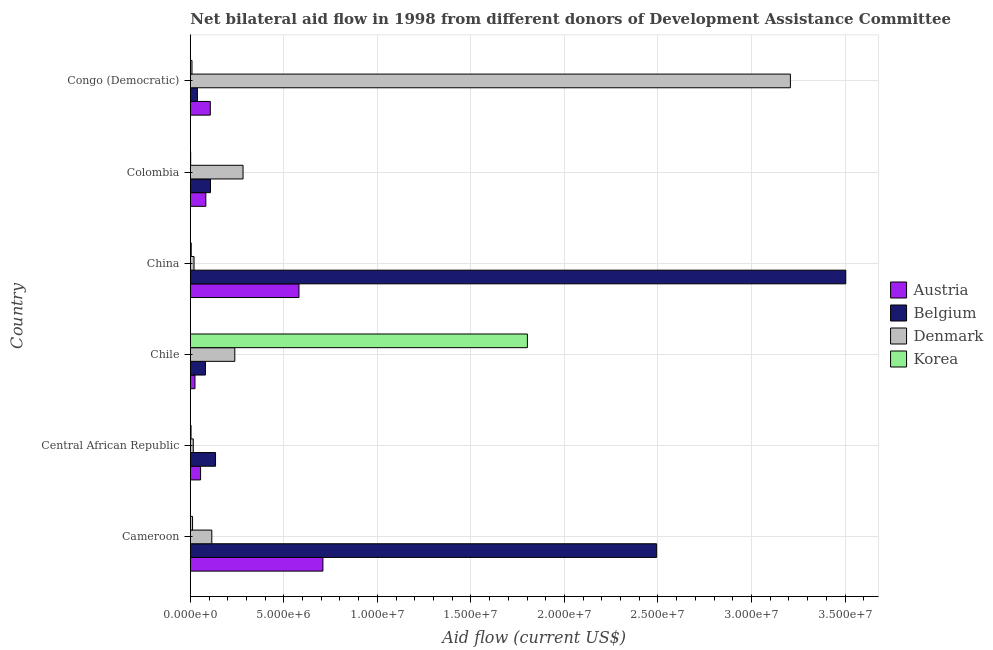How many bars are there on the 3rd tick from the bottom?
Your answer should be compact. 4. What is the label of the 4th group of bars from the top?
Provide a short and direct response. Chile. In how many cases, is the number of bars for a given country not equal to the number of legend labels?
Offer a very short reply. 0. What is the amount of aid given by belgium in Colombia?
Your response must be concise. 1.08e+06. Across all countries, what is the maximum amount of aid given by denmark?
Offer a terse response. 3.21e+07. Across all countries, what is the minimum amount of aid given by austria?
Offer a terse response. 2.50e+05. In which country was the amount of aid given by austria minimum?
Make the answer very short. Chile. What is the total amount of aid given by belgium in the graph?
Your answer should be very brief. 6.36e+07. What is the difference between the amount of aid given by korea in Cameroon and that in Chile?
Your answer should be compact. -1.79e+07. What is the difference between the amount of aid given by belgium in Cameroon and the amount of aid given by denmark in Chile?
Your answer should be very brief. 2.26e+07. What is the average amount of aid given by belgium per country?
Provide a succinct answer. 1.06e+07. What is the difference between the amount of aid given by korea and amount of aid given by belgium in Congo (Democratic)?
Your answer should be very brief. -2.90e+05. In how many countries, is the amount of aid given by belgium greater than 30000000 US$?
Provide a succinct answer. 1. Is the amount of aid given by belgium in Chile less than that in Colombia?
Ensure brevity in your answer.  Yes. What is the difference between the highest and the second highest amount of aid given by korea?
Make the answer very short. 1.79e+07. What is the difference between the highest and the lowest amount of aid given by denmark?
Keep it short and to the point. 3.19e+07. Is the sum of the amount of aid given by korea in Central African Republic and Congo (Democratic) greater than the maximum amount of aid given by denmark across all countries?
Offer a very short reply. No. Is it the case that in every country, the sum of the amount of aid given by korea and amount of aid given by austria is greater than the sum of amount of aid given by denmark and amount of aid given by belgium?
Ensure brevity in your answer.  Yes. What does the 1st bar from the bottom in Chile represents?
Your response must be concise. Austria. How many countries are there in the graph?
Keep it short and to the point. 6. What is the difference between two consecutive major ticks on the X-axis?
Ensure brevity in your answer.  5.00e+06. Where does the legend appear in the graph?
Your answer should be very brief. Center right. How many legend labels are there?
Your answer should be very brief. 4. How are the legend labels stacked?
Keep it short and to the point. Vertical. What is the title of the graph?
Make the answer very short. Net bilateral aid flow in 1998 from different donors of Development Assistance Committee. What is the label or title of the X-axis?
Provide a short and direct response. Aid flow (current US$). What is the label or title of the Y-axis?
Ensure brevity in your answer.  Country. What is the Aid flow (current US$) in Austria in Cameroon?
Your answer should be compact. 7.09e+06. What is the Aid flow (current US$) of Belgium in Cameroon?
Give a very brief answer. 2.49e+07. What is the Aid flow (current US$) in Denmark in Cameroon?
Provide a succinct answer. 1.15e+06. What is the Aid flow (current US$) in Austria in Central African Republic?
Keep it short and to the point. 5.50e+05. What is the Aid flow (current US$) of Belgium in Central African Republic?
Your response must be concise. 1.35e+06. What is the Aid flow (current US$) of Denmark in Central African Republic?
Ensure brevity in your answer.  1.60e+05. What is the Aid flow (current US$) of Austria in Chile?
Give a very brief answer. 2.50e+05. What is the Aid flow (current US$) in Belgium in Chile?
Provide a succinct answer. 8.10e+05. What is the Aid flow (current US$) of Denmark in Chile?
Your answer should be very brief. 2.38e+06. What is the Aid flow (current US$) in Korea in Chile?
Your answer should be very brief. 1.80e+07. What is the Aid flow (current US$) of Austria in China?
Provide a short and direct response. 5.81e+06. What is the Aid flow (current US$) of Belgium in China?
Your answer should be compact. 3.50e+07. What is the Aid flow (current US$) of Denmark in China?
Your answer should be compact. 2.00e+05. What is the Aid flow (current US$) of Korea in China?
Make the answer very short. 5.00e+04. What is the Aid flow (current US$) of Austria in Colombia?
Your response must be concise. 8.30e+05. What is the Aid flow (current US$) in Belgium in Colombia?
Offer a very short reply. 1.08e+06. What is the Aid flow (current US$) in Denmark in Colombia?
Offer a very short reply. 2.82e+06. What is the Aid flow (current US$) in Austria in Congo (Democratic)?
Ensure brevity in your answer.  1.07e+06. What is the Aid flow (current US$) of Belgium in Congo (Democratic)?
Give a very brief answer. 3.80e+05. What is the Aid flow (current US$) of Denmark in Congo (Democratic)?
Make the answer very short. 3.21e+07. Across all countries, what is the maximum Aid flow (current US$) in Austria?
Your response must be concise. 7.09e+06. Across all countries, what is the maximum Aid flow (current US$) in Belgium?
Ensure brevity in your answer.  3.50e+07. Across all countries, what is the maximum Aid flow (current US$) in Denmark?
Provide a short and direct response. 3.21e+07. Across all countries, what is the maximum Aid flow (current US$) in Korea?
Your response must be concise. 1.80e+07. Across all countries, what is the minimum Aid flow (current US$) of Belgium?
Provide a succinct answer. 3.80e+05. Across all countries, what is the minimum Aid flow (current US$) of Denmark?
Provide a succinct answer. 1.60e+05. What is the total Aid flow (current US$) in Austria in the graph?
Provide a short and direct response. 1.56e+07. What is the total Aid flow (current US$) of Belgium in the graph?
Make the answer very short. 6.36e+07. What is the total Aid flow (current US$) in Denmark in the graph?
Ensure brevity in your answer.  3.88e+07. What is the total Aid flow (current US$) of Korea in the graph?
Offer a very short reply. 1.83e+07. What is the difference between the Aid flow (current US$) in Austria in Cameroon and that in Central African Republic?
Provide a short and direct response. 6.54e+06. What is the difference between the Aid flow (current US$) of Belgium in Cameroon and that in Central African Republic?
Your answer should be very brief. 2.36e+07. What is the difference between the Aid flow (current US$) of Denmark in Cameroon and that in Central African Republic?
Provide a short and direct response. 9.90e+05. What is the difference between the Aid flow (current US$) in Korea in Cameroon and that in Central African Republic?
Ensure brevity in your answer.  8.00e+04. What is the difference between the Aid flow (current US$) in Austria in Cameroon and that in Chile?
Offer a very short reply. 6.84e+06. What is the difference between the Aid flow (current US$) in Belgium in Cameroon and that in Chile?
Provide a short and direct response. 2.41e+07. What is the difference between the Aid flow (current US$) of Denmark in Cameroon and that in Chile?
Your response must be concise. -1.23e+06. What is the difference between the Aid flow (current US$) in Korea in Cameroon and that in Chile?
Offer a very short reply. -1.79e+07. What is the difference between the Aid flow (current US$) of Austria in Cameroon and that in China?
Provide a short and direct response. 1.28e+06. What is the difference between the Aid flow (current US$) in Belgium in Cameroon and that in China?
Your answer should be very brief. -1.01e+07. What is the difference between the Aid flow (current US$) in Denmark in Cameroon and that in China?
Your answer should be compact. 9.50e+05. What is the difference between the Aid flow (current US$) of Korea in Cameroon and that in China?
Your response must be concise. 7.00e+04. What is the difference between the Aid flow (current US$) of Austria in Cameroon and that in Colombia?
Your answer should be very brief. 6.26e+06. What is the difference between the Aid flow (current US$) in Belgium in Cameroon and that in Colombia?
Provide a succinct answer. 2.38e+07. What is the difference between the Aid flow (current US$) of Denmark in Cameroon and that in Colombia?
Offer a very short reply. -1.67e+06. What is the difference between the Aid flow (current US$) in Korea in Cameroon and that in Colombia?
Keep it short and to the point. 1.00e+05. What is the difference between the Aid flow (current US$) of Austria in Cameroon and that in Congo (Democratic)?
Provide a short and direct response. 6.02e+06. What is the difference between the Aid flow (current US$) of Belgium in Cameroon and that in Congo (Democratic)?
Keep it short and to the point. 2.46e+07. What is the difference between the Aid flow (current US$) of Denmark in Cameroon and that in Congo (Democratic)?
Keep it short and to the point. -3.09e+07. What is the difference between the Aid flow (current US$) in Korea in Cameroon and that in Congo (Democratic)?
Make the answer very short. 3.00e+04. What is the difference between the Aid flow (current US$) of Belgium in Central African Republic and that in Chile?
Your response must be concise. 5.40e+05. What is the difference between the Aid flow (current US$) in Denmark in Central African Republic and that in Chile?
Make the answer very short. -2.22e+06. What is the difference between the Aid flow (current US$) in Korea in Central African Republic and that in Chile?
Ensure brevity in your answer.  -1.80e+07. What is the difference between the Aid flow (current US$) in Austria in Central African Republic and that in China?
Provide a succinct answer. -5.26e+06. What is the difference between the Aid flow (current US$) of Belgium in Central African Republic and that in China?
Your answer should be very brief. -3.37e+07. What is the difference between the Aid flow (current US$) of Austria in Central African Republic and that in Colombia?
Provide a short and direct response. -2.80e+05. What is the difference between the Aid flow (current US$) in Denmark in Central African Republic and that in Colombia?
Give a very brief answer. -2.66e+06. What is the difference between the Aid flow (current US$) of Austria in Central African Republic and that in Congo (Democratic)?
Your response must be concise. -5.20e+05. What is the difference between the Aid flow (current US$) in Belgium in Central African Republic and that in Congo (Democratic)?
Offer a very short reply. 9.70e+05. What is the difference between the Aid flow (current US$) of Denmark in Central African Republic and that in Congo (Democratic)?
Offer a very short reply. -3.19e+07. What is the difference between the Aid flow (current US$) of Austria in Chile and that in China?
Provide a succinct answer. -5.56e+06. What is the difference between the Aid flow (current US$) in Belgium in Chile and that in China?
Your response must be concise. -3.42e+07. What is the difference between the Aid flow (current US$) of Denmark in Chile and that in China?
Provide a succinct answer. 2.18e+06. What is the difference between the Aid flow (current US$) of Korea in Chile and that in China?
Keep it short and to the point. 1.80e+07. What is the difference between the Aid flow (current US$) in Austria in Chile and that in Colombia?
Offer a very short reply. -5.80e+05. What is the difference between the Aid flow (current US$) of Belgium in Chile and that in Colombia?
Your response must be concise. -2.70e+05. What is the difference between the Aid flow (current US$) in Denmark in Chile and that in Colombia?
Your answer should be compact. -4.40e+05. What is the difference between the Aid flow (current US$) of Korea in Chile and that in Colombia?
Provide a short and direct response. 1.80e+07. What is the difference between the Aid flow (current US$) of Austria in Chile and that in Congo (Democratic)?
Your answer should be very brief. -8.20e+05. What is the difference between the Aid flow (current US$) in Denmark in Chile and that in Congo (Democratic)?
Offer a very short reply. -2.97e+07. What is the difference between the Aid flow (current US$) in Korea in Chile and that in Congo (Democratic)?
Offer a terse response. 1.79e+07. What is the difference between the Aid flow (current US$) of Austria in China and that in Colombia?
Make the answer very short. 4.98e+06. What is the difference between the Aid flow (current US$) of Belgium in China and that in Colombia?
Your answer should be very brief. 3.40e+07. What is the difference between the Aid flow (current US$) of Denmark in China and that in Colombia?
Your answer should be very brief. -2.62e+06. What is the difference between the Aid flow (current US$) in Austria in China and that in Congo (Democratic)?
Ensure brevity in your answer.  4.74e+06. What is the difference between the Aid flow (current US$) in Belgium in China and that in Congo (Democratic)?
Ensure brevity in your answer.  3.47e+07. What is the difference between the Aid flow (current US$) of Denmark in China and that in Congo (Democratic)?
Offer a terse response. -3.19e+07. What is the difference between the Aid flow (current US$) of Korea in China and that in Congo (Democratic)?
Offer a terse response. -4.00e+04. What is the difference between the Aid flow (current US$) in Belgium in Colombia and that in Congo (Democratic)?
Your answer should be compact. 7.00e+05. What is the difference between the Aid flow (current US$) of Denmark in Colombia and that in Congo (Democratic)?
Provide a short and direct response. -2.93e+07. What is the difference between the Aid flow (current US$) in Korea in Colombia and that in Congo (Democratic)?
Offer a very short reply. -7.00e+04. What is the difference between the Aid flow (current US$) in Austria in Cameroon and the Aid flow (current US$) in Belgium in Central African Republic?
Your answer should be compact. 5.74e+06. What is the difference between the Aid flow (current US$) of Austria in Cameroon and the Aid flow (current US$) of Denmark in Central African Republic?
Your response must be concise. 6.93e+06. What is the difference between the Aid flow (current US$) of Austria in Cameroon and the Aid flow (current US$) of Korea in Central African Republic?
Give a very brief answer. 7.05e+06. What is the difference between the Aid flow (current US$) in Belgium in Cameroon and the Aid flow (current US$) in Denmark in Central African Republic?
Keep it short and to the point. 2.48e+07. What is the difference between the Aid flow (current US$) in Belgium in Cameroon and the Aid flow (current US$) in Korea in Central African Republic?
Your answer should be very brief. 2.49e+07. What is the difference between the Aid flow (current US$) of Denmark in Cameroon and the Aid flow (current US$) of Korea in Central African Republic?
Your answer should be compact. 1.11e+06. What is the difference between the Aid flow (current US$) in Austria in Cameroon and the Aid flow (current US$) in Belgium in Chile?
Give a very brief answer. 6.28e+06. What is the difference between the Aid flow (current US$) of Austria in Cameroon and the Aid flow (current US$) of Denmark in Chile?
Make the answer very short. 4.71e+06. What is the difference between the Aid flow (current US$) in Austria in Cameroon and the Aid flow (current US$) in Korea in Chile?
Give a very brief answer. -1.09e+07. What is the difference between the Aid flow (current US$) in Belgium in Cameroon and the Aid flow (current US$) in Denmark in Chile?
Keep it short and to the point. 2.26e+07. What is the difference between the Aid flow (current US$) of Belgium in Cameroon and the Aid flow (current US$) of Korea in Chile?
Keep it short and to the point. 6.91e+06. What is the difference between the Aid flow (current US$) of Denmark in Cameroon and the Aid flow (current US$) of Korea in Chile?
Your answer should be compact. -1.69e+07. What is the difference between the Aid flow (current US$) in Austria in Cameroon and the Aid flow (current US$) in Belgium in China?
Your answer should be compact. -2.80e+07. What is the difference between the Aid flow (current US$) in Austria in Cameroon and the Aid flow (current US$) in Denmark in China?
Keep it short and to the point. 6.89e+06. What is the difference between the Aid flow (current US$) in Austria in Cameroon and the Aid flow (current US$) in Korea in China?
Give a very brief answer. 7.04e+06. What is the difference between the Aid flow (current US$) in Belgium in Cameroon and the Aid flow (current US$) in Denmark in China?
Your answer should be very brief. 2.47e+07. What is the difference between the Aid flow (current US$) in Belgium in Cameroon and the Aid flow (current US$) in Korea in China?
Your answer should be compact. 2.49e+07. What is the difference between the Aid flow (current US$) of Denmark in Cameroon and the Aid flow (current US$) of Korea in China?
Your answer should be compact. 1.10e+06. What is the difference between the Aid flow (current US$) in Austria in Cameroon and the Aid flow (current US$) in Belgium in Colombia?
Offer a very short reply. 6.01e+06. What is the difference between the Aid flow (current US$) in Austria in Cameroon and the Aid flow (current US$) in Denmark in Colombia?
Provide a succinct answer. 4.27e+06. What is the difference between the Aid flow (current US$) in Austria in Cameroon and the Aid flow (current US$) in Korea in Colombia?
Offer a terse response. 7.07e+06. What is the difference between the Aid flow (current US$) of Belgium in Cameroon and the Aid flow (current US$) of Denmark in Colombia?
Offer a very short reply. 2.21e+07. What is the difference between the Aid flow (current US$) in Belgium in Cameroon and the Aid flow (current US$) in Korea in Colombia?
Your response must be concise. 2.49e+07. What is the difference between the Aid flow (current US$) in Denmark in Cameroon and the Aid flow (current US$) in Korea in Colombia?
Your response must be concise. 1.13e+06. What is the difference between the Aid flow (current US$) in Austria in Cameroon and the Aid flow (current US$) in Belgium in Congo (Democratic)?
Provide a short and direct response. 6.71e+06. What is the difference between the Aid flow (current US$) of Austria in Cameroon and the Aid flow (current US$) of Denmark in Congo (Democratic)?
Your response must be concise. -2.50e+07. What is the difference between the Aid flow (current US$) of Belgium in Cameroon and the Aid flow (current US$) of Denmark in Congo (Democratic)?
Your answer should be compact. -7.15e+06. What is the difference between the Aid flow (current US$) in Belgium in Cameroon and the Aid flow (current US$) in Korea in Congo (Democratic)?
Keep it short and to the point. 2.48e+07. What is the difference between the Aid flow (current US$) of Denmark in Cameroon and the Aid flow (current US$) of Korea in Congo (Democratic)?
Provide a short and direct response. 1.06e+06. What is the difference between the Aid flow (current US$) of Austria in Central African Republic and the Aid flow (current US$) of Belgium in Chile?
Make the answer very short. -2.60e+05. What is the difference between the Aid flow (current US$) in Austria in Central African Republic and the Aid flow (current US$) in Denmark in Chile?
Keep it short and to the point. -1.83e+06. What is the difference between the Aid flow (current US$) in Austria in Central African Republic and the Aid flow (current US$) in Korea in Chile?
Offer a very short reply. -1.75e+07. What is the difference between the Aid flow (current US$) in Belgium in Central African Republic and the Aid flow (current US$) in Denmark in Chile?
Give a very brief answer. -1.03e+06. What is the difference between the Aid flow (current US$) of Belgium in Central African Republic and the Aid flow (current US$) of Korea in Chile?
Your answer should be compact. -1.67e+07. What is the difference between the Aid flow (current US$) in Denmark in Central African Republic and the Aid flow (current US$) in Korea in Chile?
Offer a very short reply. -1.79e+07. What is the difference between the Aid flow (current US$) of Austria in Central African Republic and the Aid flow (current US$) of Belgium in China?
Give a very brief answer. -3.45e+07. What is the difference between the Aid flow (current US$) in Austria in Central African Republic and the Aid flow (current US$) in Korea in China?
Provide a short and direct response. 5.00e+05. What is the difference between the Aid flow (current US$) in Belgium in Central African Republic and the Aid flow (current US$) in Denmark in China?
Ensure brevity in your answer.  1.15e+06. What is the difference between the Aid flow (current US$) of Belgium in Central African Republic and the Aid flow (current US$) of Korea in China?
Keep it short and to the point. 1.30e+06. What is the difference between the Aid flow (current US$) in Denmark in Central African Republic and the Aid flow (current US$) in Korea in China?
Your answer should be very brief. 1.10e+05. What is the difference between the Aid flow (current US$) of Austria in Central African Republic and the Aid flow (current US$) of Belgium in Colombia?
Your answer should be very brief. -5.30e+05. What is the difference between the Aid flow (current US$) of Austria in Central African Republic and the Aid flow (current US$) of Denmark in Colombia?
Your answer should be very brief. -2.27e+06. What is the difference between the Aid flow (current US$) in Austria in Central African Republic and the Aid flow (current US$) in Korea in Colombia?
Your answer should be very brief. 5.30e+05. What is the difference between the Aid flow (current US$) of Belgium in Central African Republic and the Aid flow (current US$) of Denmark in Colombia?
Ensure brevity in your answer.  -1.47e+06. What is the difference between the Aid flow (current US$) of Belgium in Central African Republic and the Aid flow (current US$) of Korea in Colombia?
Provide a succinct answer. 1.33e+06. What is the difference between the Aid flow (current US$) in Austria in Central African Republic and the Aid flow (current US$) in Denmark in Congo (Democratic)?
Provide a short and direct response. -3.15e+07. What is the difference between the Aid flow (current US$) in Belgium in Central African Republic and the Aid flow (current US$) in Denmark in Congo (Democratic)?
Offer a terse response. -3.07e+07. What is the difference between the Aid flow (current US$) in Belgium in Central African Republic and the Aid flow (current US$) in Korea in Congo (Democratic)?
Your answer should be compact. 1.26e+06. What is the difference between the Aid flow (current US$) in Austria in Chile and the Aid flow (current US$) in Belgium in China?
Your answer should be compact. -3.48e+07. What is the difference between the Aid flow (current US$) of Austria in Chile and the Aid flow (current US$) of Denmark in China?
Keep it short and to the point. 5.00e+04. What is the difference between the Aid flow (current US$) of Austria in Chile and the Aid flow (current US$) of Korea in China?
Keep it short and to the point. 2.00e+05. What is the difference between the Aid flow (current US$) in Belgium in Chile and the Aid flow (current US$) in Denmark in China?
Give a very brief answer. 6.10e+05. What is the difference between the Aid flow (current US$) in Belgium in Chile and the Aid flow (current US$) in Korea in China?
Make the answer very short. 7.60e+05. What is the difference between the Aid flow (current US$) of Denmark in Chile and the Aid flow (current US$) of Korea in China?
Your answer should be compact. 2.33e+06. What is the difference between the Aid flow (current US$) of Austria in Chile and the Aid flow (current US$) of Belgium in Colombia?
Ensure brevity in your answer.  -8.30e+05. What is the difference between the Aid flow (current US$) of Austria in Chile and the Aid flow (current US$) of Denmark in Colombia?
Your response must be concise. -2.57e+06. What is the difference between the Aid flow (current US$) in Austria in Chile and the Aid flow (current US$) in Korea in Colombia?
Your answer should be very brief. 2.30e+05. What is the difference between the Aid flow (current US$) of Belgium in Chile and the Aid flow (current US$) of Denmark in Colombia?
Give a very brief answer. -2.01e+06. What is the difference between the Aid flow (current US$) in Belgium in Chile and the Aid flow (current US$) in Korea in Colombia?
Your answer should be very brief. 7.90e+05. What is the difference between the Aid flow (current US$) in Denmark in Chile and the Aid flow (current US$) in Korea in Colombia?
Ensure brevity in your answer.  2.36e+06. What is the difference between the Aid flow (current US$) of Austria in Chile and the Aid flow (current US$) of Belgium in Congo (Democratic)?
Offer a terse response. -1.30e+05. What is the difference between the Aid flow (current US$) of Austria in Chile and the Aid flow (current US$) of Denmark in Congo (Democratic)?
Offer a terse response. -3.18e+07. What is the difference between the Aid flow (current US$) of Belgium in Chile and the Aid flow (current US$) of Denmark in Congo (Democratic)?
Your answer should be compact. -3.13e+07. What is the difference between the Aid flow (current US$) in Belgium in Chile and the Aid flow (current US$) in Korea in Congo (Democratic)?
Provide a short and direct response. 7.20e+05. What is the difference between the Aid flow (current US$) in Denmark in Chile and the Aid flow (current US$) in Korea in Congo (Democratic)?
Keep it short and to the point. 2.29e+06. What is the difference between the Aid flow (current US$) of Austria in China and the Aid flow (current US$) of Belgium in Colombia?
Provide a short and direct response. 4.73e+06. What is the difference between the Aid flow (current US$) in Austria in China and the Aid flow (current US$) in Denmark in Colombia?
Offer a very short reply. 2.99e+06. What is the difference between the Aid flow (current US$) of Austria in China and the Aid flow (current US$) of Korea in Colombia?
Keep it short and to the point. 5.79e+06. What is the difference between the Aid flow (current US$) in Belgium in China and the Aid flow (current US$) in Denmark in Colombia?
Provide a short and direct response. 3.22e+07. What is the difference between the Aid flow (current US$) in Belgium in China and the Aid flow (current US$) in Korea in Colombia?
Give a very brief answer. 3.50e+07. What is the difference between the Aid flow (current US$) of Denmark in China and the Aid flow (current US$) of Korea in Colombia?
Your answer should be compact. 1.80e+05. What is the difference between the Aid flow (current US$) of Austria in China and the Aid flow (current US$) of Belgium in Congo (Democratic)?
Your response must be concise. 5.43e+06. What is the difference between the Aid flow (current US$) of Austria in China and the Aid flow (current US$) of Denmark in Congo (Democratic)?
Offer a terse response. -2.63e+07. What is the difference between the Aid flow (current US$) of Austria in China and the Aid flow (current US$) of Korea in Congo (Democratic)?
Keep it short and to the point. 5.72e+06. What is the difference between the Aid flow (current US$) of Belgium in China and the Aid flow (current US$) of Denmark in Congo (Democratic)?
Ensure brevity in your answer.  2.96e+06. What is the difference between the Aid flow (current US$) of Belgium in China and the Aid flow (current US$) of Korea in Congo (Democratic)?
Offer a terse response. 3.50e+07. What is the difference between the Aid flow (current US$) of Austria in Colombia and the Aid flow (current US$) of Denmark in Congo (Democratic)?
Offer a very short reply. -3.12e+07. What is the difference between the Aid flow (current US$) in Austria in Colombia and the Aid flow (current US$) in Korea in Congo (Democratic)?
Make the answer very short. 7.40e+05. What is the difference between the Aid flow (current US$) in Belgium in Colombia and the Aid flow (current US$) in Denmark in Congo (Democratic)?
Your answer should be very brief. -3.10e+07. What is the difference between the Aid flow (current US$) of Belgium in Colombia and the Aid flow (current US$) of Korea in Congo (Democratic)?
Keep it short and to the point. 9.90e+05. What is the difference between the Aid flow (current US$) of Denmark in Colombia and the Aid flow (current US$) of Korea in Congo (Democratic)?
Offer a terse response. 2.73e+06. What is the average Aid flow (current US$) of Austria per country?
Offer a terse response. 2.60e+06. What is the average Aid flow (current US$) of Belgium per country?
Make the answer very short. 1.06e+07. What is the average Aid flow (current US$) in Denmark per country?
Your response must be concise. 6.46e+06. What is the average Aid flow (current US$) of Korea per country?
Offer a terse response. 3.06e+06. What is the difference between the Aid flow (current US$) in Austria and Aid flow (current US$) in Belgium in Cameroon?
Offer a terse response. -1.78e+07. What is the difference between the Aid flow (current US$) of Austria and Aid flow (current US$) of Denmark in Cameroon?
Provide a short and direct response. 5.94e+06. What is the difference between the Aid flow (current US$) in Austria and Aid flow (current US$) in Korea in Cameroon?
Ensure brevity in your answer.  6.97e+06. What is the difference between the Aid flow (current US$) of Belgium and Aid flow (current US$) of Denmark in Cameroon?
Your answer should be very brief. 2.38e+07. What is the difference between the Aid flow (current US$) of Belgium and Aid flow (current US$) of Korea in Cameroon?
Your response must be concise. 2.48e+07. What is the difference between the Aid flow (current US$) in Denmark and Aid flow (current US$) in Korea in Cameroon?
Keep it short and to the point. 1.03e+06. What is the difference between the Aid flow (current US$) of Austria and Aid flow (current US$) of Belgium in Central African Republic?
Ensure brevity in your answer.  -8.00e+05. What is the difference between the Aid flow (current US$) in Austria and Aid flow (current US$) in Denmark in Central African Republic?
Keep it short and to the point. 3.90e+05. What is the difference between the Aid flow (current US$) of Austria and Aid flow (current US$) of Korea in Central African Republic?
Provide a succinct answer. 5.10e+05. What is the difference between the Aid flow (current US$) of Belgium and Aid flow (current US$) of Denmark in Central African Republic?
Ensure brevity in your answer.  1.19e+06. What is the difference between the Aid flow (current US$) of Belgium and Aid flow (current US$) of Korea in Central African Republic?
Your response must be concise. 1.31e+06. What is the difference between the Aid flow (current US$) in Austria and Aid flow (current US$) in Belgium in Chile?
Provide a succinct answer. -5.60e+05. What is the difference between the Aid flow (current US$) of Austria and Aid flow (current US$) of Denmark in Chile?
Keep it short and to the point. -2.13e+06. What is the difference between the Aid flow (current US$) in Austria and Aid flow (current US$) in Korea in Chile?
Ensure brevity in your answer.  -1.78e+07. What is the difference between the Aid flow (current US$) of Belgium and Aid flow (current US$) of Denmark in Chile?
Your answer should be very brief. -1.57e+06. What is the difference between the Aid flow (current US$) of Belgium and Aid flow (current US$) of Korea in Chile?
Your answer should be compact. -1.72e+07. What is the difference between the Aid flow (current US$) in Denmark and Aid flow (current US$) in Korea in Chile?
Provide a short and direct response. -1.56e+07. What is the difference between the Aid flow (current US$) of Austria and Aid flow (current US$) of Belgium in China?
Provide a short and direct response. -2.92e+07. What is the difference between the Aid flow (current US$) in Austria and Aid flow (current US$) in Denmark in China?
Provide a short and direct response. 5.61e+06. What is the difference between the Aid flow (current US$) in Austria and Aid flow (current US$) in Korea in China?
Make the answer very short. 5.76e+06. What is the difference between the Aid flow (current US$) in Belgium and Aid flow (current US$) in Denmark in China?
Ensure brevity in your answer.  3.48e+07. What is the difference between the Aid flow (current US$) in Belgium and Aid flow (current US$) in Korea in China?
Keep it short and to the point. 3.50e+07. What is the difference between the Aid flow (current US$) in Austria and Aid flow (current US$) in Denmark in Colombia?
Offer a terse response. -1.99e+06. What is the difference between the Aid flow (current US$) in Austria and Aid flow (current US$) in Korea in Colombia?
Ensure brevity in your answer.  8.10e+05. What is the difference between the Aid flow (current US$) in Belgium and Aid flow (current US$) in Denmark in Colombia?
Offer a terse response. -1.74e+06. What is the difference between the Aid flow (current US$) in Belgium and Aid flow (current US$) in Korea in Colombia?
Make the answer very short. 1.06e+06. What is the difference between the Aid flow (current US$) of Denmark and Aid flow (current US$) of Korea in Colombia?
Keep it short and to the point. 2.80e+06. What is the difference between the Aid flow (current US$) of Austria and Aid flow (current US$) of Belgium in Congo (Democratic)?
Offer a very short reply. 6.90e+05. What is the difference between the Aid flow (current US$) in Austria and Aid flow (current US$) in Denmark in Congo (Democratic)?
Your response must be concise. -3.10e+07. What is the difference between the Aid flow (current US$) in Austria and Aid flow (current US$) in Korea in Congo (Democratic)?
Offer a very short reply. 9.80e+05. What is the difference between the Aid flow (current US$) of Belgium and Aid flow (current US$) of Denmark in Congo (Democratic)?
Provide a succinct answer. -3.17e+07. What is the difference between the Aid flow (current US$) of Denmark and Aid flow (current US$) of Korea in Congo (Democratic)?
Provide a short and direct response. 3.20e+07. What is the ratio of the Aid flow (current US$) of Austria in Cameroon to that in Central African Republic?
Offer a very short reply. 12.89. What is the ratio of the Aid flow (current US$) of Belgium in Cameroon to that in Central African Republic?
Provide a short and direct response. 18.47. What is the ratio of the Aid flow (current US$) of Denmark in Cameroon to that in Central African Republic?
Offer a very short reply. 7.19. What is the ratio of the Aid flow (current US$) in Korea in Cameroon to that in Central African Republic?
Provide a succinct answer. 3. What is the ratio of the Aid flow (current US$) of Austria in Cameroon to that in Chile?
Give a very brief answer. 28.36. What is the ratio of the Aid flow (current US$) of Belgium in Cameroon to that in Chile?
Give a very brief answer. 30.78. What is the ratio of the Aid flow (current US$) in Denmark in Cameroon to that in Chile?
Make the answer very short. 0.48. What is the ratio of the Aid flow (current US$) in Korea in Cameroon to that in Chile?
Offer a terse response. 0.01. What is the ratio of the Aid flow (current US$) of Austria in Cameroon to that in China?
Your response must be concise. 1.22. What is the ratio of the Aid flow (current US$) of Belgium in Cameroon to that in China?
Make the answer very short. 0.71. What is the ratio of the Aid flow (current US$) of Denmark in Cameroon to that in China?
Your response must be concise. 5.75. What is the ratio of the Aid flow (current US$) in Austria in Cameroon to that in Colombia?
Your response must be concise. 8.54. What is the ratio of the Aid flow (current US$) in Belgium in Cameroon to that in Colombia?
Your answer should be very brief. 23.08. What is the ratio of the Aid flow (current US$) of Denmark in Cameroon to that in Colombia?
Provide a succinct answer. 0.41. What is the ratio of the Aid flow (current US$) in Korea in Cameroon to that in Colombia?
Provide a short and direct response. 6. What is the ratio of the Aid flow (current US$) of Austria in Cameroon to that in Congo (Democratic)?
Your answer should be compact. 6.63. What is the ratio of the Aid flow (current US$) in Belgium in Cameroon to that in Congo (Democratic)?
Provide a short and direct response. 65.61. What is the ratio of the Aid flow (current US$) in Denmark in Cameroon to that in Congo (Democratic)?
Offer a very short reply. 0.04. What is the ratio of the Aid flow (current US$) in Korea in Cameroon to that in Congo (Democratic)?
Offer a very short reply. 1.33. What is the ratio of the Aid flow (current US$) in Austria in Central African Republic to that in Chile?
Provide a succinct answer. 2.2. What is the ratio of the Aid flow (current US$) in Belgium in Central African Republic to that in Chile?
Your answer should be very brief. 1.67. What is the ratio of the Aid flow (current US$) of Denmark in Central African Republic to that in Chile?
Make the answer very short. 0.07. What is the ratio of the Aid flow (current US$) of Korea in Central African Republic to that in Chile?
Your response must be concise. 0. What is the ratio of the Aid flow (current US$) in Austria in Central African Republic to that in China?
Keep it short and to the point. 0.09. What is the ratio of the Aid flow (current US$) of Belgium in Central African Republic to that in China?
Your answer should be very brief. 0.04. What is the ratio of the Aid flow (current US$) of Denmark in Central African Republic to that in China?
Keep it short and to the point. 0.8. What is the ratio of the Aid flow (current US$) of Austria in Central African Republic to that in Colombia?
Your response must be concise. 0.66. What is the ratio of the Aid flow (current US$) of Belgium in Central African Republic to that in Colombia?
Provide a succinct answer. 1.25. What is the ratio of the Aid flow (current US$) of Denmark in Central African Republic to that in Colombia?
Provide a succinct answer. 0.06. What is the ratio of the Aid flow (current US$) of Austria in Central African Republic to that in Congo (Democratic)?
Ensure brevity in your answer.  0.51. What is the ratio of the Aid flow (current US$) in Belgium in Central African Republic to that in Congo (Democratic)?
Keep it short and to the point. 3.55. What is the ratio of the Aid flow (current US$) in Denmark in Central African Republic to that in Congo (Democratic)?
Provide a succinct answer. 0.01. What is the ratio of the Aid flow (current US$) in Korea in Central African Republic to that in Congo (Democratic)?
Ensure brevity in your answer.  0.44. What is the ratio of the Aid flow (current US$) of Austria in Chile to that in China?
Ensure brevity in your answer.  0.04. What is the ratio of the Aid flow (current US$) in Belgium in Chile to that in China?
Keep it short and to the point. 0.02. What is the ratio of the Aid flow (current US$) of Denmark in Chile to that in China?
Keep it short and to the point. 11.9. What is the ratio of the Aid flow (current US$) in Korea in Chile to that in China?
Offer a very short reply. 360.4. What is the ratio of the Aid flow (current US$) in Austria in Chile to that in Colombia?
Keep it short and to the point. 0.3. What is the ratio of the Aid flow (current US$) of Belgium in Chile to that in Colombia?
Offer a very short reply. 0.75. What is the ratio of the Aid flow (current US$) of Denmark in Chile to that in Colombia?
Provide a short and direct response. 0.84. What is the ratio of the Aid flow (current US$) of Korea in Chile to that in Colombia?
Provide a succinct answer. 901. What is the ratio of the Aid flow (current US$) of Austria in Chile to that in Congo (Democratic)?
Keep it short and to the point. 0.23. What is the ratio of the Aid flow (current US$) in Belgium in Chile to that in Congo (Democratic)?
Your answer should be very brief. 2.13. What is the ratio of the Aid flow (current US$) of Denmark in Chile to that in Congo (Democratic)?
Keep it short and to the point. 0.07. What is the ratio of the Aid flow (current US$) in Korea in Chile to that in Congo (Democratic)?
Offer a terse response. 200.22. What is the ratio of the Aid flow (current US$) in Belgium in China to that in Colombia?
Offer a very short reply. 32.44. What is the ratio of the Aid flow (current US$) in Denmark in China to that in Colombia?
Offer a terse response. 0.07. What is the ratio of the Aid flow (current US$) of Korea in China to that in Colombia?
Offer a terse response. 2.5. What is the ratio of the Aid flow (current US$) of Austria in China to that in Congo (Democratic)?
Your answer should be very brief. 5.43. What is the ratio of the Aid flow (current US$) in Belgium in China to that in Congo (Democratic)?
Keep it short and to the point. 92.21. What is the ratio of the Aid flow (current US$) of Denmark in China to that in Congo (Democratic)?
Give a very brief answer. 0.01. What is the ratio of the Aid flow (current US$) in Korea in China to that in Congo (Democratic)?
Keep it short and to the point. 0.56. What is the ratio of the Aid flow (current US$) in Austria in Colombia to that in Congo (Democratic)?
Offer a very short reply. 0.78. What is the ratio of the Aid flow (current US$) in Belgium in Colombia to that in Congo (Democratic)?
Ensure brevity in your answer.  2.84. What is the ratio of the Aid flow (current US$) in Denmark in Colombia to that in Congo (Democratic)?
Keep it short and to the point. 0.09. What is the ratio of the Aid flow (current US$) of Korea in Colombia to that in Congo (Democratic)?
Keep it short and to the point. 0.22. What is the difference between the highest and the second highest Aid flow (current US$) of Austria?
Offer a terse response. 1.28e+06. What is the difference between the highest and the second highest Aid flow (current US$) of Belgium?
Your answer should be very brief. 1.01e+07. What is the difference between the highest and the second highest Aid flow (current US$) of Denmark?
Provide a succinct answer. 2.93e+07. What is the difference between the highest and the second highest Aid flow (current US$) in Korea?
Offer a terse response. 1.79e+07. What is the difference between the highest and the lowest Aid flow (current US$) in Austria?
Your answer should be very brief. 6.84e+06. What is the difference between the highest and the lowest Aid flow (current US$) in Belgium?
Give a very brief answer. 3.47e+07. What is the difference between the highest and the lowest Aid flow (current US$) in Denmark?
Ensure brevity in your answer.  3.19e+07. What is the difference between the highest and the lowest Aid flow (current US$) in Korea?
Keep it short and to the point. 1.80e+07. 